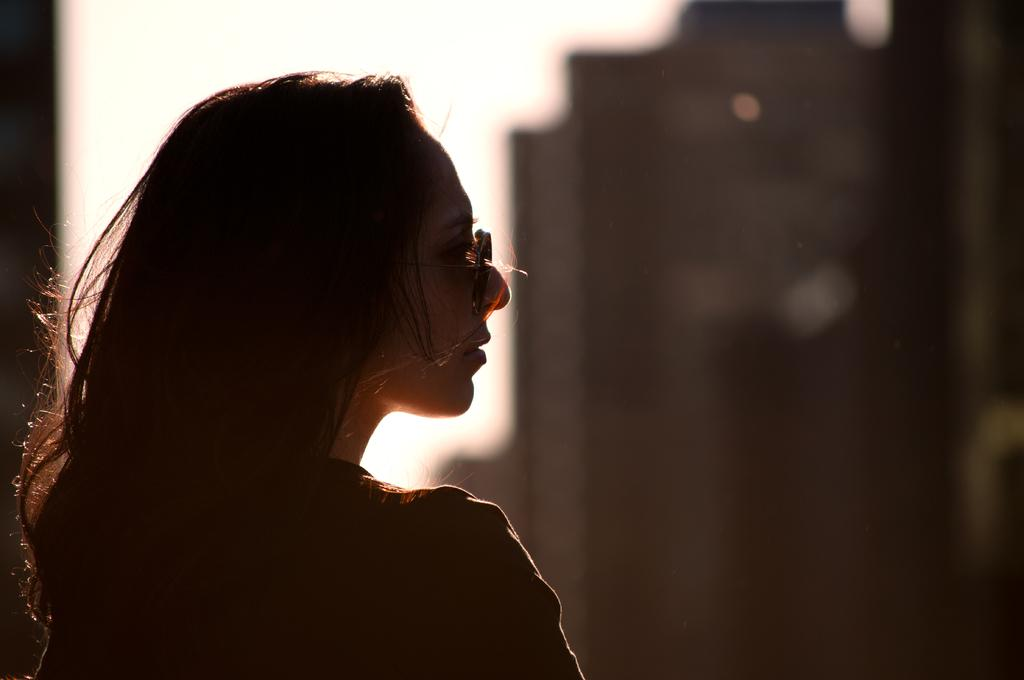Who is the main subject in the image? There is a woman in the image. What can be observed about the background of the image? The background of the image is blurred. What part of the natural environment is visible in the image? The sky is visible in the image. What type of powder can be seen falling from the sky in the image? There is no powder falling from the sky in the image; the sky is visible but not depicted as having any falling substances. 